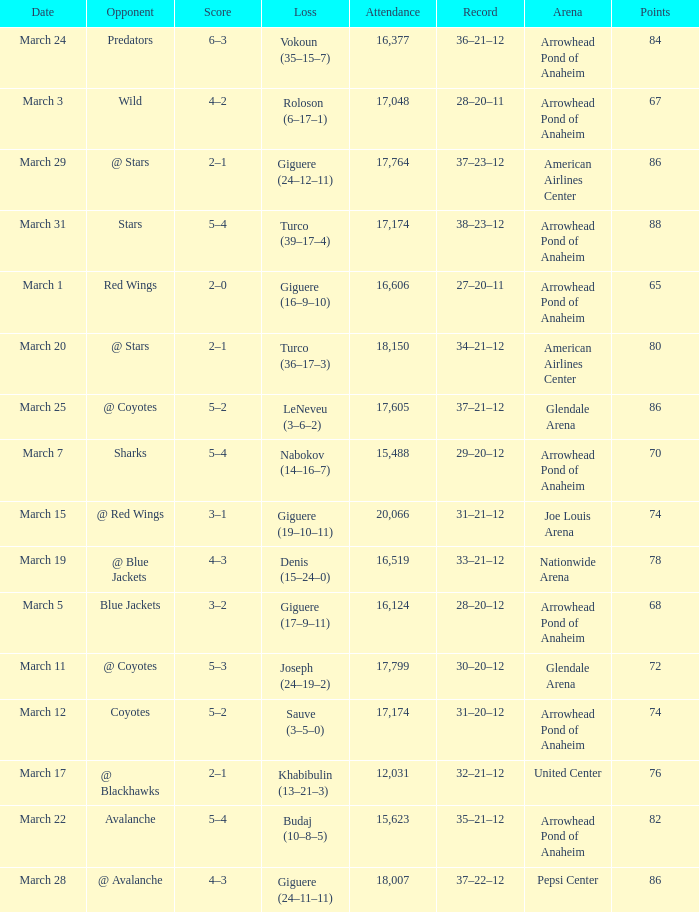What is the Attendance at Joe Louis Arena? 20066.0. 